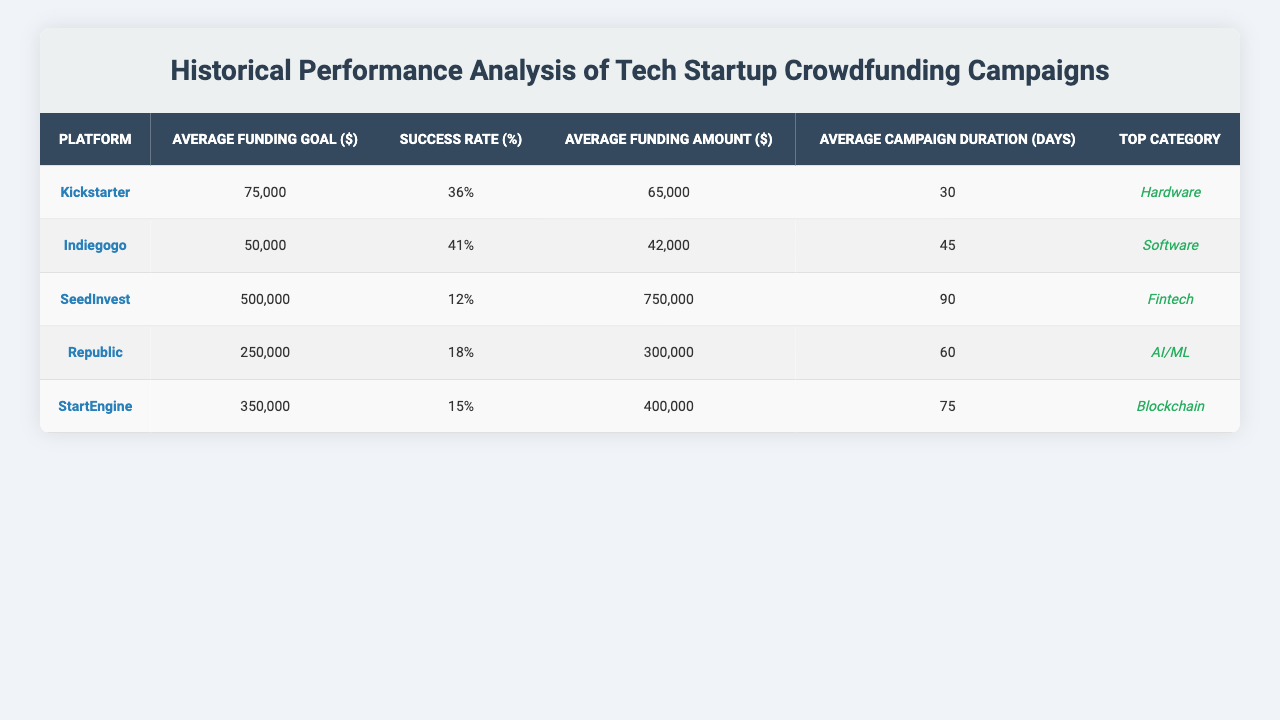What is the average funding goal for Kickstarter campaigns? The table shows that the average funding goal for Kickstarter campaigns is $75,000.
Answer: $75,000 What is the success rate for SeedInvest campaigns? According to the table, the success rate for SeedInvest campaigns is 12%.
Answer: 12% Which platform has the highest average funding amount? The table indicates that SeedInvest has the highest average funding amount at $750,000, compared to other platforms.
Answer: SeedInvest How long do Indiegogo campaigns usually last on average? The table states that the average campaign duration for Indiegogo is 45 days.
Answer: 45 days Is the top category for StartEngine campaigns Blockchain? The table confirms that the top category for StartEngine is indeed Blockchain.
Answer: Yes What is the difference in success rate between Kickstarter and Indiegogo? The success rate for Kickstarter is 36%, and for Indiegogo it is 41%. The difference is 41% - 36% = 5%.
Answer: 5% What is the average funding goal for all platforms combined? The average funding goals for each platform are $75,000, $50,000, $500,000, $250,000, and $350,000. Summing these gives $1,325,000, and dividing by 5 (the number of platforms) results in an average of $265,000.
Answer: $265,000 Which platform has the largest average campaign duration? The average campaign duration for each platform is 30 days for Kickstarter, 45 days for Indiegogo, 90 days for SeedInvest, 60 days for Republic, and 75 days for StartEngine. The largest duration is 90 days for SeedInvest.
Answer: SeedInvest If a campaign on Republic aims for $250,000, how does it compare to the average funding amount received there? The average funding amount on Republic is $300,000, which is higher than the funding goal of $250,000. This implies that campaigns often exceed their goals.
Answer: Higher What platform has a success rate less than 20%, and what is its average funding amount? The platforms with a success rate less than 20% are SeedInvest (12% with an average funding amount of $750,000), Republic (18% with an average of $300,000), and StartEngine (15% with an average of $400,000).
Answer: SeedInvest, $750,000 